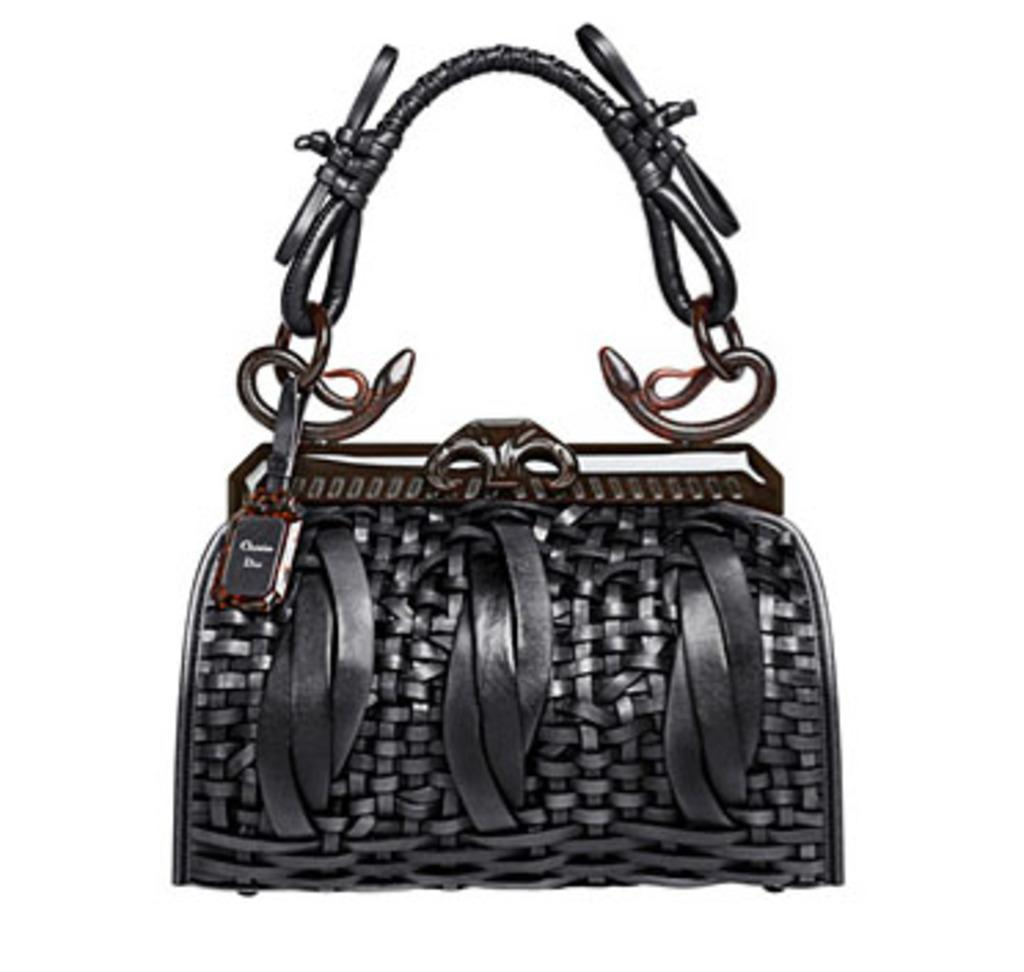What type of accessory is visible in the image? There is a woman's handbag in the image. Can you describe the handbag in more detail? Unfortunately, the image only shows the handbag, and no further details are available. What type of copper coil can be seen inside the handbag in the image? There is no copper coil visible inside the handbag in the image, as the image only shows the handbag itself and does not provide any information about its contents. 